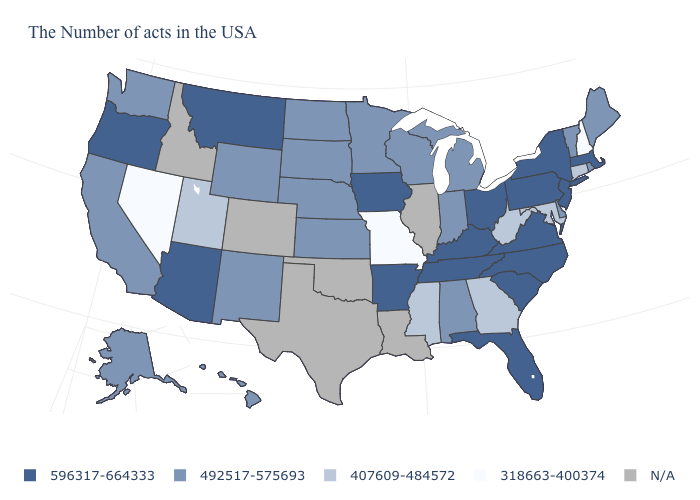What is the value of Nebraska?
Answer briefly. 492517-575693. What is the lowest value in the MidWest?
Be succinct. 318663-400374. Name the states that have a value in the range 318663-400374?
Concise answer only. New Hampshire, Missouri, Nevada. Does the first symbol in the legend represent the smallest category?
Short answer required. No. Which states have the highest value in the USA?
Give a very brief answer. Massachusetts, New York, New Jersey, Pennsylvania, Virginia, North Carolina, South Carolina, Ohio, Florida, Kentucky, Tennessee, Arkansas, Iowa, Montana, Arizona, Oregon. What is the value of New Mexico?
Be succinct. 492517-575693. Is the legend a continuous bar?
Keep it brief. No. What is the value of Pennsylvania?
Keep it brief. 596317-664333. Name the states that have a value in the range 318663-400374?
Answer briefly. New Hampshire, Missouri, Nevada. Among the states that border Texas , does Arkansas have the highest value?
Concise answer only. Yes. How many symbols are there in the legend?
Give a very brief answer. 5. What is the value of Alabama?
Quick response, please. 492517-575693. Among the states that border Connecticut , which have the lowest value?
Answer briefly. Rhode Island. What is the value of Rhode Island?
Be succinct. 492517-575693. 